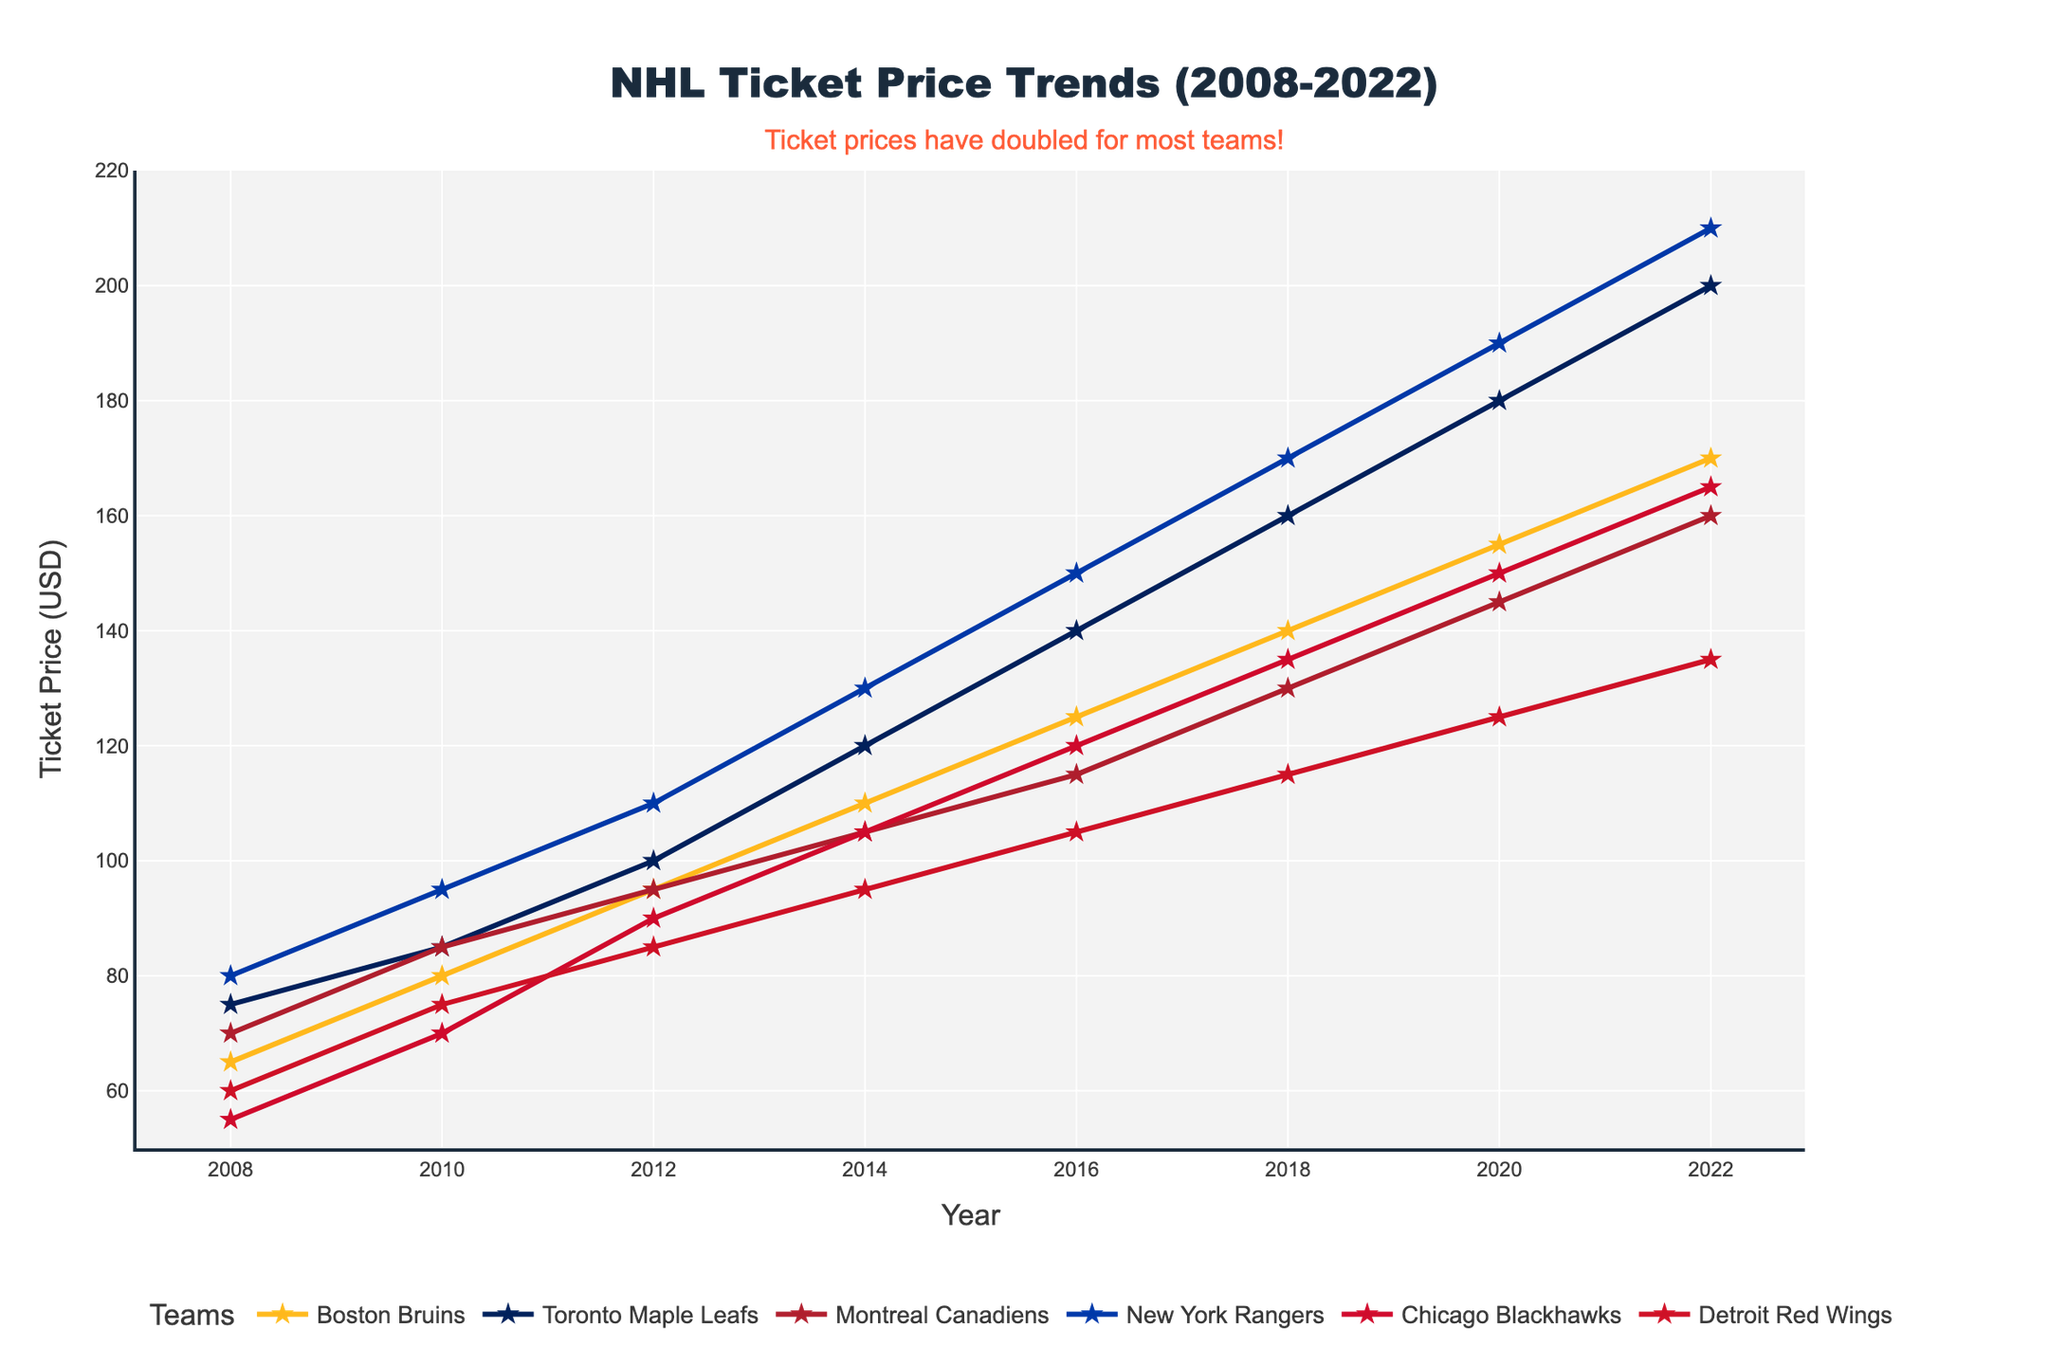What was the average ticket price for the Boston Bruins in 2012? To find the average ticket price of the Boston Bruins in 2012, locate the value on the Y-axis corresponding to 2012.
Answer: 95 USD How much did the ticket price for the Toronto Maple Leafs increase from 2008 to 2022? Subtract the ticket price in 2008 from the ticket price in 2022 for the Toronto Maple Leafs: 200 - 75 = 125.
Answer: 125 USD Which team had the highest ticket prices in 2018? Locate the year 2018 on the X-axis and compare the ticket prices for all teams by checking which line reaches the highest on the Y-axis.
Answer: New York Rangers Between which years did the Chicago Blackhawks see the biggest increase in ticket prices? Look for the largest vertical distance between consecutive points for the Chicago Blackhawks' line.
Answer: 2014 to 2016 What is the range of ticket prices for the Detroit Red Wings over the 15 years? The range is the difference between the highest and lowest ticket prices from 2008 to 2022 for the Detroit Red Wings: 135 - 60 = 75.
Answer: 75 USD In which year were the ticket prices the same for the Boston Bruins and Montreal Canadiens? Find a year where the two lines (representing Boston Bruins and Montreal Canadiens) meet at the same point on the Y-axis.
Answer: 2012 Which team had the steepest increase in ticket prices between 2008 and 2022? Compare the overall slopes of all teams' lines from 2008 to 2022 and identify the steepest one.
Answer: Toronto Maple Leafs How did the ticket price trend for the New York Rangers compare to the Montreal Canadiens from 2012 to 2016? Compare the slopes of the New York Rangers and Montreal Canadiens lines between 2012-2016. Both lines rise, but the Rangers increase more steeply.
Answer: New York Rangers increased more steeply What was the ticket price difference between the highest and lowest team in 2020? Subtract the lowest ticket price from the highest ticket price in 2020: 190 - 125 = 65.
Answer: 65 USD How much more expensive were the tickets for the New York Rangers compared to the Detroit Red Wings in 2014? Subtract the ticket price of the Detroit Red Wings from the New York Rangers in 2014: 130 - 95 = 35.
Answer: 35 USD 